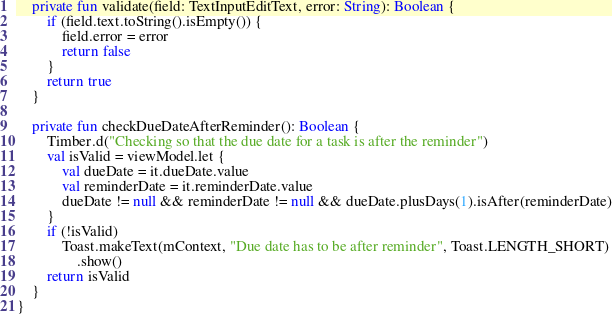Convert code to text. <code><loc_0><loc_0><loc_500><loc_500><_Kotlin_>    private fun validate(field: TextInputEditText, error: String): Boolean {
        if (field.text.toString().isEmpty()) {
            field.error = error
            return false
        }
        return true
    }

    private fun checkDueDateAfterReminder(): Boolean {
        Timber.d("Checking so that the due date for a task is after the reminder")
        val isValid = viewModel.let {
            val dueDate = it.dueDate.value
            val reminderDate = it.reminderDate.value
            dueDate != null && reminderDate != null && dueDate.plusDays(1).isAfter(reminderDate)
        }
        if (!isValid)
            Toast.makeText(mContext, "Due date has to be after reminder", Toast.LENGTH_SHORT)
                .show()
        return isValid
    }
}
</code> 